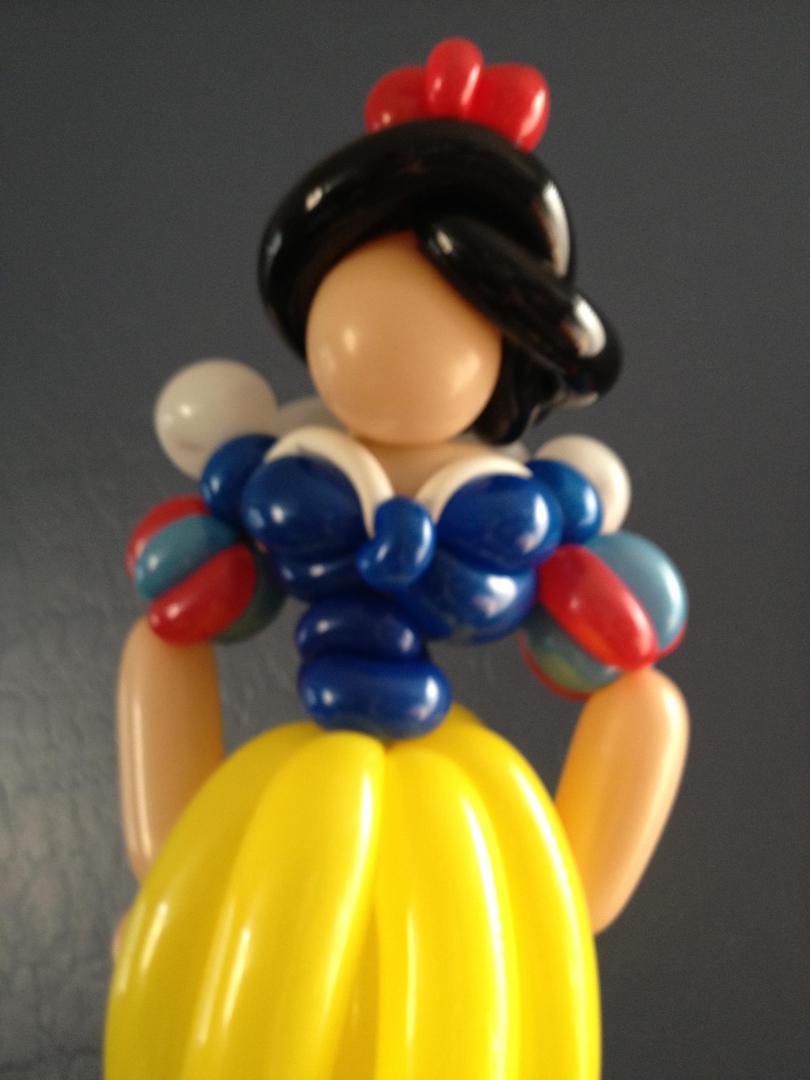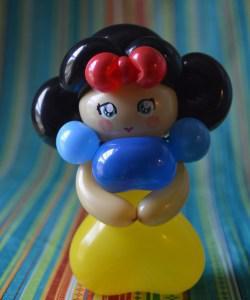The first image is the image on the left, the second image is the image on the right. Evaluate the accuracy of this statement regarding the images: "There are two princess balloon figures looking forward.". Is it true? Answer yes or no. Yes. The first image is the image on the left, the second image is the image on the right. For the images displayed, is the sentence "Four faces are visible." factually correct? Answer yes or no. No. 